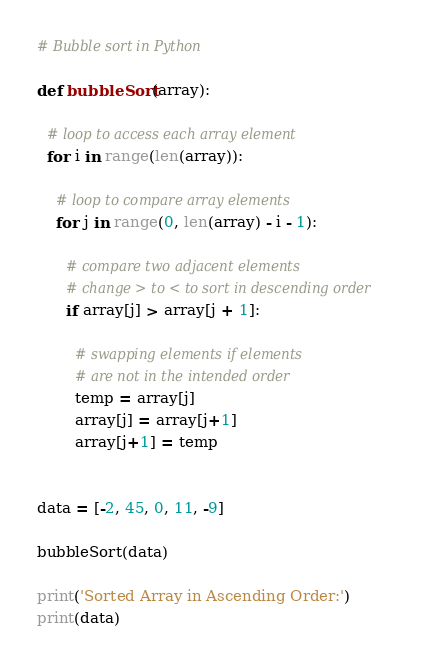<code> <loc_0><loc_0><loc_500><loc_500><_Python_># Bubble sort in Python

def bubbleSort(array):
    
  # loop to access each array element
  for i in range(len(array)):

    # loop to compare array elements
    for j in range(0, len(array) - i - 1):

      # compare two adjacent elements
      # change > to < to sort in descending order
      if array[j] > array[j + 1]:

        # swapping elements if elements
        # are not in the intended order
        temp = array[j]
        array[j] = array[j+1]
        array[j+1] = temp


data = [-2, 45, 0, 11, -9]

bubbleSort(data)

print('Sorted Array in Ascending Order:')
print(data)
</code> 